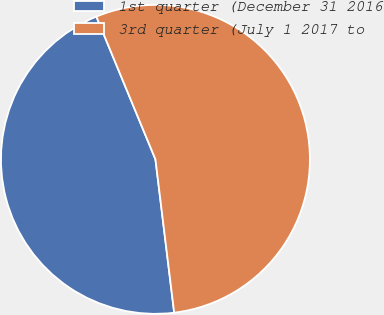<chart> <loc_0><loc_0><loc_500><loc_500><pie_chart><fcel>1st quarter (December 31 2016<fcel>3rd quarter (July 1 2017 to<nl><fcel>45.69%<fcel>54.31%<nl></chart> 